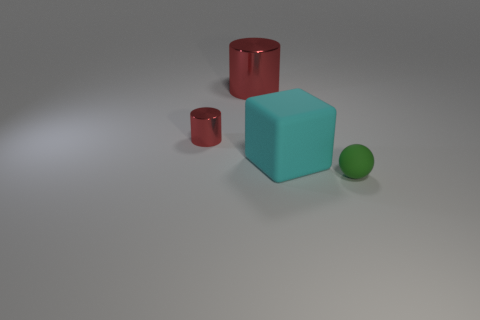There is another metal cylinder that is the same color as the tiny cylinder; what size is it?
Make the answer very short. Large. Are there any other shiny objects that have the same color as the big metallic thing?
Your answer should be very brief. Yes. There is a cyan object; is it the same size as the metal thing that is to the right of the tiny red object?
Your answer should be compact. Yes. There is a small thing that is on the right side of the large matte object; what is its color?
Make the answer very short. Green. The tiny object left of the cyan matte object has what shape?
Provide a short and direct response. Cylinder. What number of cyan things are either tiny balls or cylinders?
Your answer should be very brief. 0. Does the tiny red object have the same material as the big cylinder?
Provide a short and direct response. Yes. There is a big block; what number of spheres are on the right side of it?
Offer a very short reply. 1. What is the object that is both left of the large block and to the right of the small red metallic cylinder made of?
Give a very brief answer. Metal. How many balls are yellow metal things or tiny green things?
Provide a succinct answer. 1. 